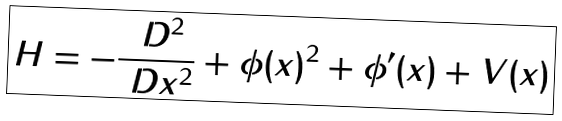Convert formula to latex. <formula><loc_0><loc_0><loc_500><loc_500>\boxed { H = - \frac { \ D ^ { 2 } } { \ D x ^ { 2 } } + \phi ( x ) ^ { 2 } + \phi ^ { \prime } ( x ) + V ( x ) }</formula> 